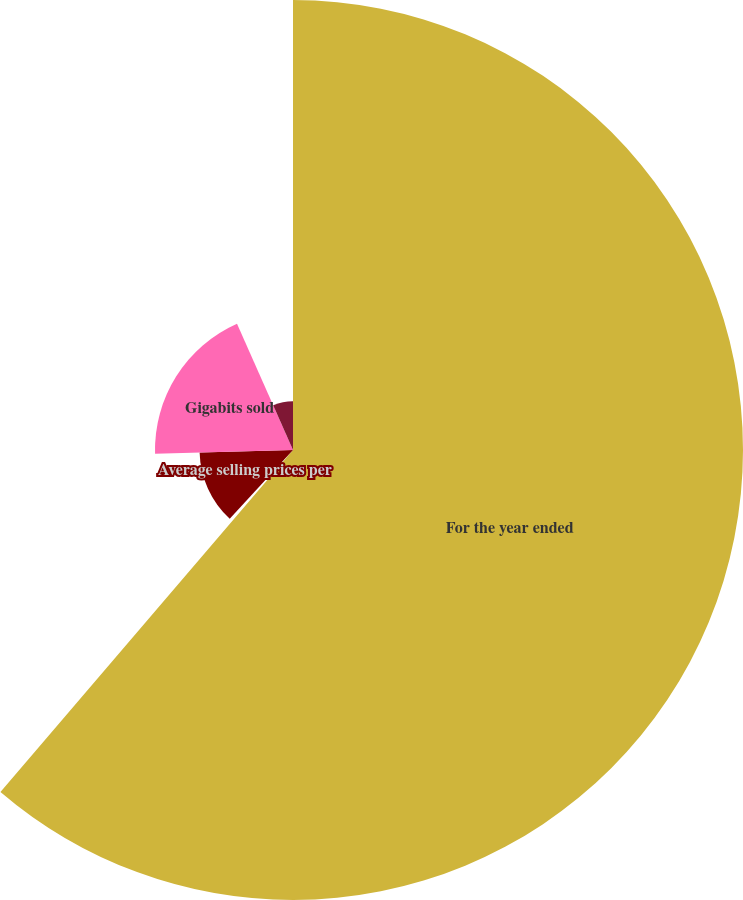Convert chart to OTSL. <chart><loc_0><loc_0><loc_500><loc_500><pie_chart><fcel>For the year ended<fcel>Net sales<fcel>Average selling prices per<fcel>Gigabits sold<fcel>Cost per gigabit<nl><fcel>61.27%<fcel>0.58%<fcel>12.72%<fcel>18.79%<fcel>6.65%<nl></chart> 